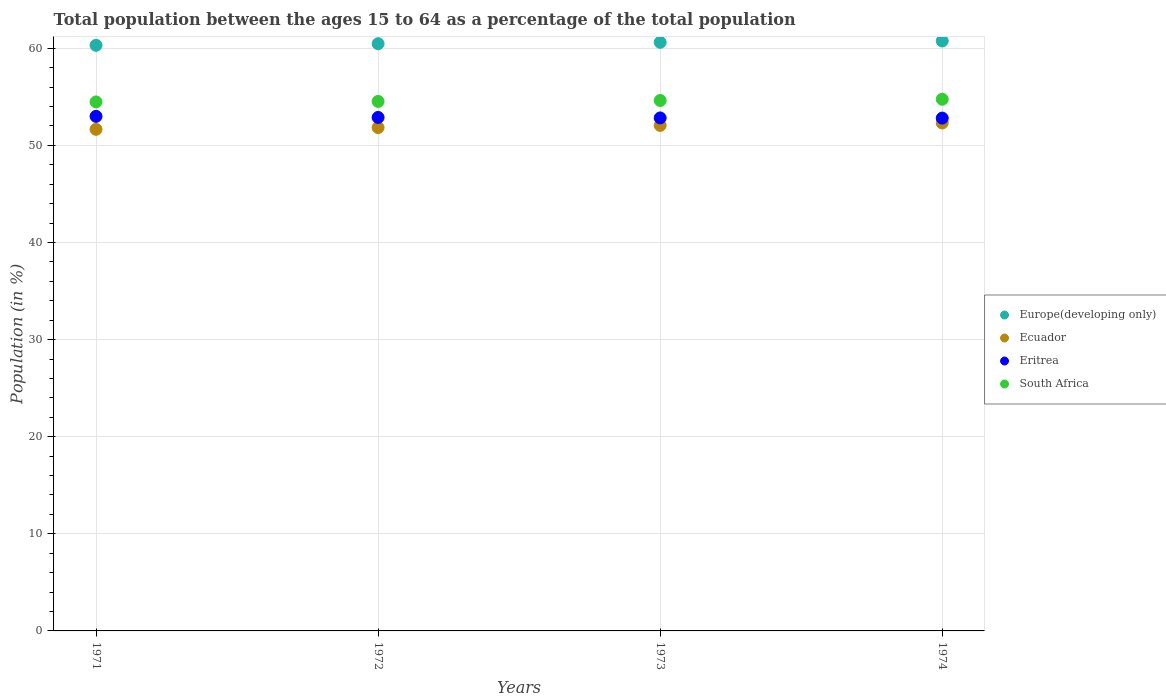What is the percentage of the population ages 15 to 64 in Ecuador in 1972?
Ensure brevity in your answer.  51.83. Across all years, what is the maximum percentage of the population ages 15 to 64 in Europe(developing only)?
Make the answer very short. 60.75. Across all years, what is the minimum percentage of the population ages 15 to 64 in Europe(developing only)?
Keep it short and to the point. 60.3. In which year was the percentage of the population ages 15 to 64 in Ecuador maximum?
Provide a succinct answer. 1974. In which year was the percentage of the population ages 15 to 64 in Ecuador minimum?
Keep it short and to the point. 1971. What is the total percentage of the population ages 15 to 64 in Europe(developing only) in the graph?
Ensure brevity in your answer.  242.13. What is the difference between the percentage of the population ages 15 to 64 in Ecuador in 1971 and that in 1972?
Your answer should be very brief. -0.18. What is the difference between the percentage of the population ages 15 to 64 in South Africa in 1973 and the percentage of the population ages 15 to 64 in Europe(developing only) in 1971?
Your response must be concise. -5.68. What is the average percentage of the population ages 15 to 64 in South Africa per year?
Your response must be concise. 54.59. In the year 1973, what is the difference between the percentage of the population ages 15 to 64 in Ecuador and percentage of the population ages 15 to 64 in South Africa?
Provide a short and direct response. -2.57. In how many years, is the percentage of the population ages 15 to 64 in South Africa greater than 12?
Provide a succinct answer. 4. What is the ratio of the percentage of the population ages 15 to 64 in Europe(developing only) in 1971 to that in 1972?
Keep it short and to the point. 1. Is the percentage of the population ages 15 to 64 in Eritrea in 1972 less than that in 1973?
Make the answer very short. No. What is the difference between the highest and the second highest percentage of the population ages 15 to 64 in Eritrea?
Provide a succinct answer. 0.11. What is the difference between the highest and the lowest percentage of the population ages 15 to 64 in Eritrea?
Your answer should be very brief. 0.18. Is the sum of the percentage of the population ages 15 to 64 in South Africa in 1971 and 1974 greater than the maximum percentage of the population ages 15 to 64 in Eritrea across all years?
Your response must be concise. Yes. Is it the case that in every year, the sum of the percentage of the population ages 15 to 64 in Eritrea and percentage of the population ages 15 to 64 in Europe(developing only)  is greater than the sum of percentage of the population ages 15 to 64 in South Africa and percentage of the population ages 15 to 64 in Ecuador?
Offer a terse response. Yes. Does the percentage of the population ages 15 to 64 in Eritrea monotonically increase over the years?
Your response must be concise. No. How many years are there in the graph?
Make the answer very short. 4. Are the values on the major ticks of Y-axis written in scientific E-notation?
Your answer should be very brief. No. Does the graph contain any zero values?
Your answer should be compact. No. What is the title of the graph?
Offer a terse response. Total population between the ages 15 to 64 as a percentage of the total population. What is the Population (in %) of Europe(developing only) in 1971?
Give a very brief answer. 60.3. What is the Population (in %) in Ecuador in 1971?
Your answer should be very brief. 51.65. What is the Population (in %) of Eritrea in 1971?
Offer a terse response. 52.99. What is the Population (in %) of South Africa in 1971?
Your answer should be very brief. 54.47. What is the Population (in %) in Europe(developing only) in 1972?
Give a very brief answer. 60.47. What is the Population (in %) in Ecuador in 1972?
Provide a succinct answer. 51.83. What is the Population (in %) of Eritrea in 1972?
Offer a very short reply. 52.88. What is the Population (in %) of South Africa in 1972?
Your response must be concise. 54.53. What is the Population (in %) in Europe(developing only) in 1973?
Provide a short and direct response. 60.61. What is the Population (in %) of Ecuador in 1973?
Ensure brevity in your answer.  52.05. What is the Population (in %) of Eritrea in 1973?
Offer a very short reply. 52.83. What is the Population (in %) in South Africa in 1973?
Provide a succinct answer. 54.62. What is the Population (in %) in Europe(developing only) in 1974?
Make the answer very short. 60.75. What is the Population (in %) in Ecuador in 1974?
Keep it short and to the point. 52.31. What is the Population (in %) in Eritrea in 1974?
Keep it short and to the point. 52.81. What is the Population (in %) of South Africa in 1974?
Keep it short and to the point. 54.75. Across all years, what is the maximum Population (in %) in Europe(developing only)?
Your answer should be compact. 60.75. Across all years, what is the maximum Population (in %) in Ecuador?
Ensure brevity in your answer.  52.31. Across all years, what is the maximum Population (in %) of Eritrea?
Your response must be concise. 52.99. Across all years, what is the maximum Population (in %) of South Africa?
Keep it short and to the point. 54.75. Across all years, what is the minimum Population (in %) in Europe(developing only)?
Give a very brief answer. 60.3. Across all years, what is the minimum Population (in %) in Ecuador?
Your answer should be very brief. 51.65. Across all years, what is the minimum Population (in %) in Eritrea?
Your answer should be compact. 52.81. Across all years, what is the minimum Population (in %) of South Africa?
Make the answer very short. 54.47. What is the total Population (in %) in Europe(developing only) in the graph?
Provide a succinct answer. 242.13. What is the total Population (in %) of Ecuador in the graph?
Your answer should be very brief. 207.85. What is the total Population (in %) of Eritrea in the graph?
Provide a short and direct response. 211.49. What is the total Population (in %) of South Africa in the graph?
Offer a very short reply. 218.37. What is the difference between the Population (in %) in Europe(developing only) in 1971 and that in 1972?
Provide a succinct answer. -0.17. What is the difference between the Population (in %) in Ecuador in 1971 and that in 1972?
Ensure brevity in your answer.  -0.18. What is the difference between the Population (in %) in Eritrea in 1971 and that in 1972?
Provide a succinct answer. 0.11. What is the difference between the Population (in %) of South Africa in 1971 and that in 1972?
Offer a terse response. -0.05. What is the difference between the Population (in %) of Europe(developing only) in 1971 and that in 1973?
Keep it short and to the point. -0.31. What is the difference between the Population (in %) in Ecuador in 1971 and that in 1973?
Offer a very short reply. -0.4. What is the difference between the Population (in %) of Eritrea in 1971 and that in 1973?
Offer a very short reply. 0.16. What is the difference between the Population (in %) in South Africa in 1971 and that in 1973?
Keep it short and to the point. -0.15. What is the difference between the Population (in %) in Europe(developing only) in 1971 and that in 1974?
Provide a succinct answer. -0.45. What is the difference between the Population (in %) of Ecuador in 1971 and that in 1974?
Offer a terse response. -0.65. What is the difference between the Population (in %) in Eritrea in 1971 and that in 1974?
Provide a succinct answer. 0.18. What is the difference between the Population (in %) in South Africa in 1971 and that in 1974?
Ensure brevity in your answer.  -0.27. What is the difference between the Population (in %) of Europe(developing only) in 1972 and that in 1973?
Ensure brevity in your answer.  -0.14. What is the difference between the Population (in %) of Ecuador in 1972 and that in 1973?
Give a very brief answer. -0.22. What is the difference between the Population (in %) in South Africa in 1972 and that in 1973?
Your response must be concise. -0.1. What is the difference between the Population (in %) in Europe(developing only) in 1972 and that in 1974?
Provide a short and direct response. -0.28. What is the difference between the Population (in %) of Ecuador in 1972 and that in 1974?
Provide a succinct answer. -0.47. What is the difference between the Population (in %) in Eritrea in 1972 and that in 1974?
Your answer should be compact. 0.07. What is the difference between the Population (in %) of South Africa in 1972 and that in 1974?
Provide a short and direct response. -0.22. What is the difference between the Population (in %) of Europe(developing only) in 1973 and that in 1974?
Keep it short and to the point. -0.14. What is the difference between the Population (in %) of Ecuador in 1973 and that in 1974?
Give a very brief answer. -0.25. What is the difference between the Population (in %) of Eritrea in 1973 and that in 1974?
Your response must be concise. 0.02. What is the difference between the Population (in %) in South Africa in 1973 and that in 1974?
Your answer should be very brief. -0.13. What is the difference between the Population (in %) of Europe(developing only) in 1971 and the Population (in %) of Ecuador in 1972?
Offer a terse response. 8.47. What is the difference between the Population (in %) of Europe(developing only) in 1971 and the Population (in %) of Eritrea in 1972?
Provide a succinct answer. 7.42. What is the difference between the Population (in %) in Europe(developing only) in 1971 and the Population (in %) in South Africa in 1972?
Your response must be concise. 5.77. What is the difference between the Population (in %) in Ecuador in 1971 and the Population (in %) in Eritrea in 1972?
Ensure brevity in your answer.  -1.22. What is the difference between the Population (in %) of Ecuador in 1971 and the Population (in %) of South Africa in 1972?
Ensure brevity in your answer.  -2.87. What is the difference between the Population (in %) of Eritrea in 1971 and the Population (in %) of South Africa in 1972?
Your response must be concise. -1.54. What is the difference between the Population (in %) of Europe(developing only) in 1971 and the Population (in %) of Ecuador in 1973?
Ensure brevity in your answer.  8.25. What is the difference between the Population (in %) in Europe(developing only) in 1971 and the Population (in %) in Eritrea in 1973?
Your answer should be compact. 7.47. What is the difference between the Population (in %) of Europe(developing only) in 1971 and the Population (in %) of South Africa in 1973?
Your answer should be compact. 5.68. What is the difference between the Population (in %) of Ecuador in 1971 and the Population (in %) of Eritrea in 1973?
Give a very brief answer. -1.17. What is the difference between the Population (in %) in Ecuador in 1971 and the Population (in %) in South Africa in 1973?
Your answer should be compact. -2.97. What is the difference between the Population (in %) of Eritrea in 1971 and the Population (in %) of South Africa in 1973?
Ensure brevity in your answer.  -1.63. What is the difference between the Population (in %) of Europe(developing only) in 1971 and the Population (in %) of Ecuador in 1974?
Your response must be concise. 7.99. What is the difference between the Population (in %) of Europe(developing only) in 1971 and the Population (in %) of Eritrea in 1974?
Make the answer very short. 7.49. What is the difference between the Population (in %) of Europe(developing only) in 1971 and the Population (in %) of South Africa in 1974?
Provide a succinct answer. 5.55. What is the difference between the Population (in %) in Ecuador in 1971 and the Population (in %) in Eritrea in 1974?
Offer a terse response. -1.15. What is the difference between the Population (in %) in Ecuador in 1971 and the Population (in %) in South Africa in 1974?
Make the answer very short. -3.1. What is the difference between the Population (in %) in Eritrea in 1971 and the Population (in %) in South Africa in 1974?
Your answer should be very brief. -1.76. What is the difference between the Population (in %) in Europe(developing only) in 1972 and the Population (in %) in Ecuador in 1973?
Keep it short and to the point. 8.41. What is the difference between the Population (in %) of Europe(developing only) in 1972 and the Population (in %) of Eritrea in 1973?
Provide a succinct answer. 7.64. What is the difference between the Population (in %) of Europe(developing only) in 1972 and the Population (in %) of South Africa in 1973?
Keep it short and to the point. 5.85. What is the difference between the Population (in %) in Ecuador in 1972 and the Population (in %) in Eritrea in 1973?
Offer a terse response. -0.99. What is the difference between the Population (in %) in Ecuador in 1972 and the Population (in %) in South Africa in 1973?
Give a very brief answer. -2.79. What is the difference between the Population (in %) of Eritrea in 1972 and the Population (in %) of South Africa in 1973?
Your answer should be very brief. -1.75. What is the difference between the Population (in %) in Europe(developing only) in 1972 and the Population (in %) in Ecuador in 1974?
Offer a very short reply. 8.16. What is the difference between the Population (in %) in Europe(developing only) in 1972 and the Population (in %) in Eritrea in 1974?
Your answer should be compact. 7.66. What is the difference between the Population (in %) of Europe(developing only) in 1972 and the Population (in %) of South Africa in 1974?
Your answer should be compact. 5.72. What is the difference between the Population (in %) in Ecuador in 1972 and the Population (in %) in Eritrea in 1974?
Ensure brevity in your answer.  -0.97. What is the difference between the Population (in %) in Ecuador in 1972 and the Population (in %) in South Africa in 1974?
Keep it short and to the point. -2.91. What is the difference between the Population (in %) of Eritrea in 1972 and the Population (in %) of South Africa in 1974?
Ensure brevity in your answer.  -1.87. What is the difference between the Population (in %) of Europe(developing only) in 1973 and the Population (in %) of Ecuador in 1974?
Your response must be concise. 8.3. What is the difference between the Population (in %) of Europe(developing only) in 1973 and the Population (in %) of Eritrea in 1974?
Ensure brevity in your answer.  7.8. What is the difference between the Population (in %) of Europe(developing only) in 1973 and the Population (in %) of South Africa in 1974?
Give a very brief answer. 5.86. What is the difference between the Population (in %) in Ecuador in 1973 and the Population (in %) in Eritrea in 1974?
Give a very brief answer. -0.75. What is the difference between the Population (in %) in Ecuador in 1973 and the Population (in %) in South Africa in 1974?
Your response must be concise. -2.69. What is the difference between the Population (in %) in Eritrea in 1973 and the Population (in %) in South Africa in 1974?
Give a very brief answer. -1.92. What is the average Population (in %) of Europe(developing only) per year?
Your answer should be compact. 60.53. What is the average Population (in %) of Ecuador per year?
Give a very brief answer. 51.96. What is the average Population (in %) of Eritrea per year?
Your answer should be very brief. 52.87. What is the average Population (in %) of South Africa per year?
Keep it short and to the point. 54.59. In the year 1971, what is the difference between the Population (in %) of Europe(developing only) and Population (in %) of Ecuador?
Your answer should be very brief. 8.65. In the year 1971, what is the difference between the Population (in %) in Europe(developing only) and Population (in %) in Eritrea?
Your answer should be compact. 7.31. In the year 1971, what is the difference between the Population (in %) in Europe(developing only) and Population (in %) in South Africa?
Give a very brief answer. 5.83. In the year 1971, what is the difference between the Population (in %) in Ecuador and Population (in %) in Eritrea?
Offer a terse response. -1.33. In the year 1971, what is the difference between the Population (in %) in Ecuador and Population (in %) in South Africa?
Offer a terse response. -2.82. In the year 1971, what is the difference between the Population (in %) of Eritrea and Population (in %) of South Africa?
Provide a short and direct response. -1.49. In the year 1972, what is the difference between the Population (in %) in Europe(developing only) and Population (in %) in Ecuador?
Keep it short and to the point. 8.63. In the year 1972, what is the difference between the Population (in %) in Europe(developing only) and Population (in %) in Eritrea?
Keep it short and to the point. 7.59. In the year 1972, what is the difference between the Population (in %) in Europe(developing only) and Population (in %) in South Africa?
Make the answer very short. 5.94. In the year 1972, what is the difference between the Population (in %) of Ecuador and Population (in %) of Eritrea?
Provide a succinct answer. -1.04. In the year 1972, what is the difference between the Population (in %) in Ecuador and Population (in %) in South Africa?
Provide a succinct answer. -2.69. In the year 1972, what is the difference between the Population (in %) in Eritrea and Population (in %) in South Africa?
Provide a succinct answer. -1.65. In the year 1973, what is the difference between the Population (in %) in Europe(developing only) and Population (in %) in Ecuador?
Your answer should be compact. 8.55. In the year 1973, what is the difference between the Population (in %) of Europe(developing only) and Population (in %) of Eritrea?
Provide a succinct answer. 7.78. In the year 1973, what is the difference between the Population (in %) in Europe(developing only) and Population (in %) in South Africa?
Give a very brief answer. 5.99. In the year 1973, what is the difference between the Population (in %) of Ecuador and Population (in %) of Eritrea?
Offer a very short reply. -0.77. In the year 1973, what is the difference between the Population (in %) in Ecuador and Population (in %) in South Africa?
Your response must be concise. -2.57. In the year 1973, what is the difference between the Population (in %) of Eritrea and Population (in %) of South Africa?
Your answer should be very brief. -1.8. In the year 1974, what is the difference between the Population (in %) of Europe(developing only) and Population (in %) of Ecuador?
Offer a terse response. 8.44. In the year 1974, what is the difference between the Population (in %) in Europe(developing only) and Population (in %) in Eritrea?
Give a very brief answer. 7.94. In the year 1974, what is the difference between the Population (in %) in Europe(developing only) and Population (in %) in South Africa?
Your response must be concise. 6. In the year 1974, what is the difference between the Population (in %) of Ecuador and Population (in %) of Eritrea?
Make the answer very short. -0.5. In the year 1974, what is the difference between the Population (in %) in Ecuador and Population (in %) in South Africa?
Keep it short and to the point. -2.44. In the year 1974, what is the difference between the Population (in %) of Eritrea and Population (in %) of South Africa?
Your answer should be very brief. -1.94. What is the ratio of the Population (in %) of Europe(developing only) in 1971 to that in 1972?
Your answer should be very brief. 1. What is the ratio of the Population (in %) of Eritrea in 1971 to that in 1972?
Provide a short and direct response. 1. What is the ratio of the Population (in %) of Europe(developing only) in 1971 to that in 1973?
Provide a short and direct response. 0.99. What is the ratio of the Population (in %) in Eritrea in 1971 to that in 1973?
Keep it short and to the point. 1. What is the ratio of the Population (in %) of South Africa in 1971 to that in 1973?
Your response must be concise. 1. What is the ratio of the Population (in %) in Europe(developing only) in 1971 to that in 1974?
Your answer should be very brief. 0.99. What is the ratio of the Population (in %) of Ecuador in 1971 to that in 1974?
Keep it short and to the point. 0.99. What is the ratio of the Population (in %) of Eritrea in 1971 to that in 1974?
Ensure brevity in your answer.  1. What is the ratio of the Population (in %) in Europe(developing only) in 1972 to that in 1973?
Your response must be concise. 1. What is the ratio of the Population (in %) in Ecuador in 1972 to that in 1973?
Offer a very short reply. 1. What is the ratio of the Population (in %) of Europe(developing only) in 1972 to that in 1974?
Make the answer very short. 1. What is the ratio of the Population (in %) in Eritrea in 1972 to that in 1974?
Make the answer very short. 1. What is the ratio of the Population (in %) of South Africa in 1972 to that in 1974?
Your response must be concise. 1. What is the ratio of the Population (in %) in Europe(developing only) in 1973 to that in 1974?
Provide a succinct answer. 1. What is the difference between the highest and the second highest Population (in %) in Europe(developing only)?
Keep it short and to the point. 0.14. What is the difference between the highest and the second highest Population (in %) of Ecuador?
Your response must be concise. 0.25. What is the difference between the highest and the second highest Population (in %) in Eritrea?
Offer a very short reply. 0.11. What is the difference between the highest and the second highest Population (in %) in South Africa?
Make the answer very short. 0.13. What is the difference between the highest and the lowest Population (in %) in Europe(developing only)?
Give a very brief answer. 0.45. What is the difference between the highest and the lowest Population (in %) of Ecuador?
Offer a terse response. 0.65. What is the difference between the highest and the lowest Population (in %) of Eritrea?
Your answer should be very brief. 0.18. What is the difference between the highest and the lowest Population (in %) in South Africa?
Offer a terse response. 0.27. 